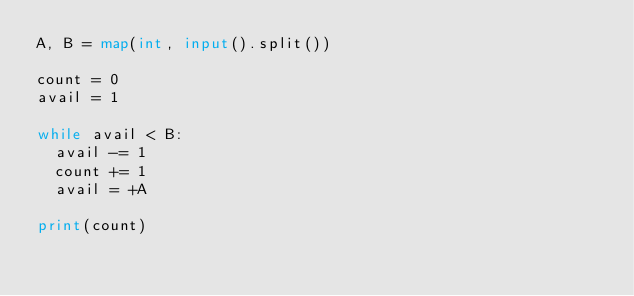<code> <loc_0><loc_0><loc_500><loc_500><_Python_>A, B = map(int, input().split())

count = 0
avail = 1

while avail < B:
  avail -= 1
  count += 1
  avail = +A

print(count)
</code> 